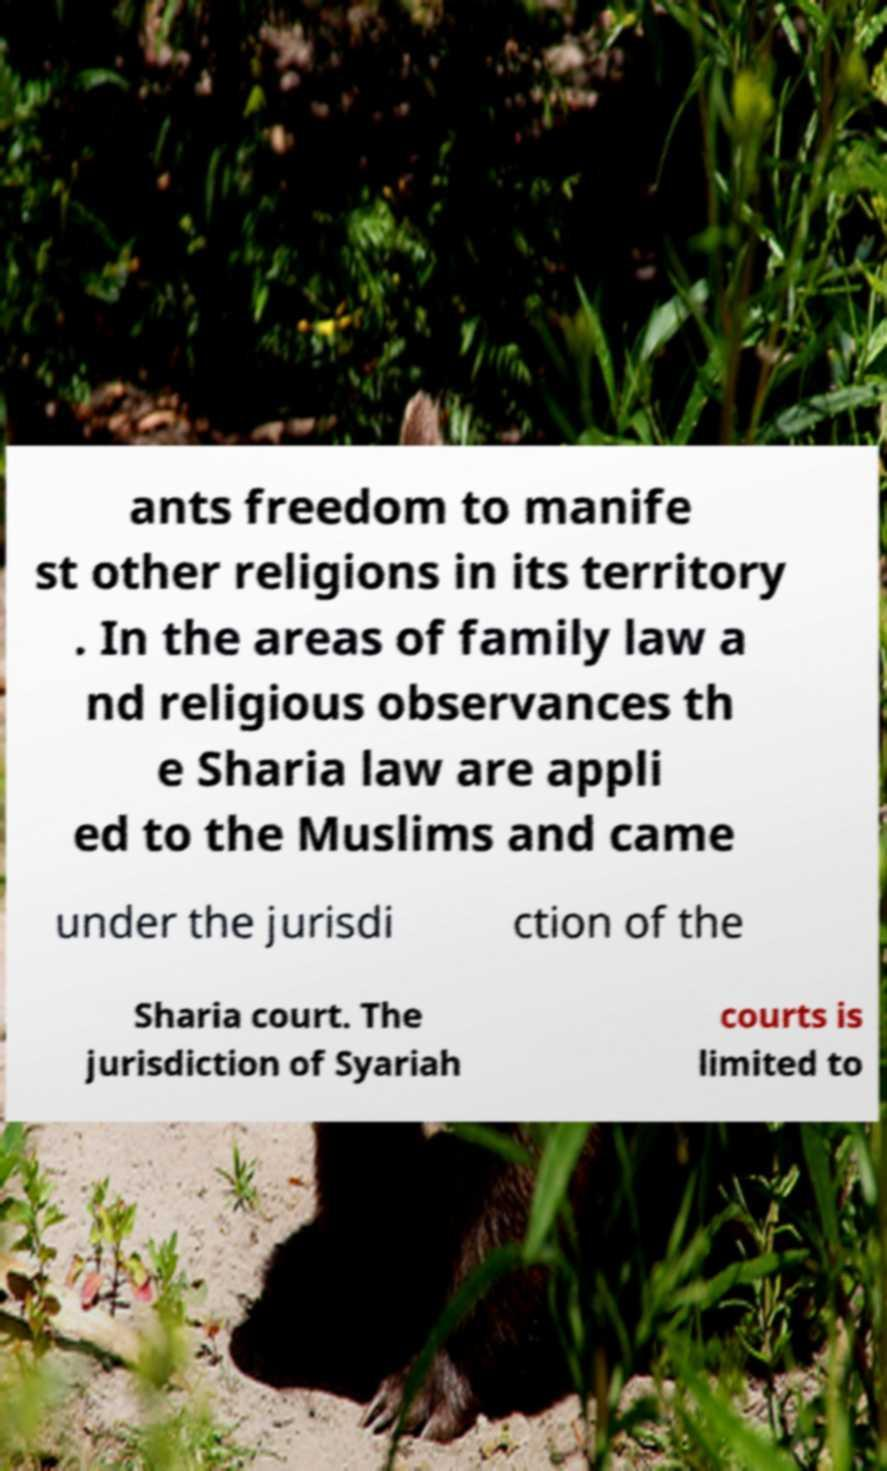Can you accurately transcribe the text from the provided image for me? ants freedom to manife st other religions in its territory . In the areas of family law a nd religious observances th e Sharia law are appli ed to the Muslims and came under the jurisdi ction of the Sharia court. The jurisdiction of Syariah courts is limited to 